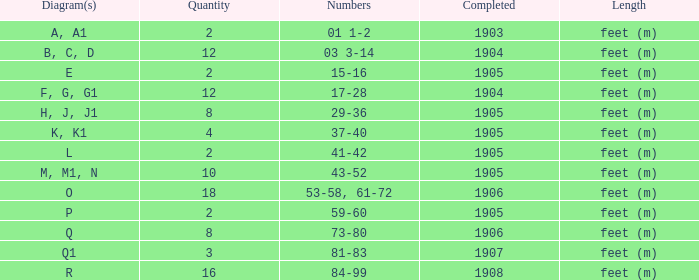What are the values for the item finished before 1904? 01 1-2. 